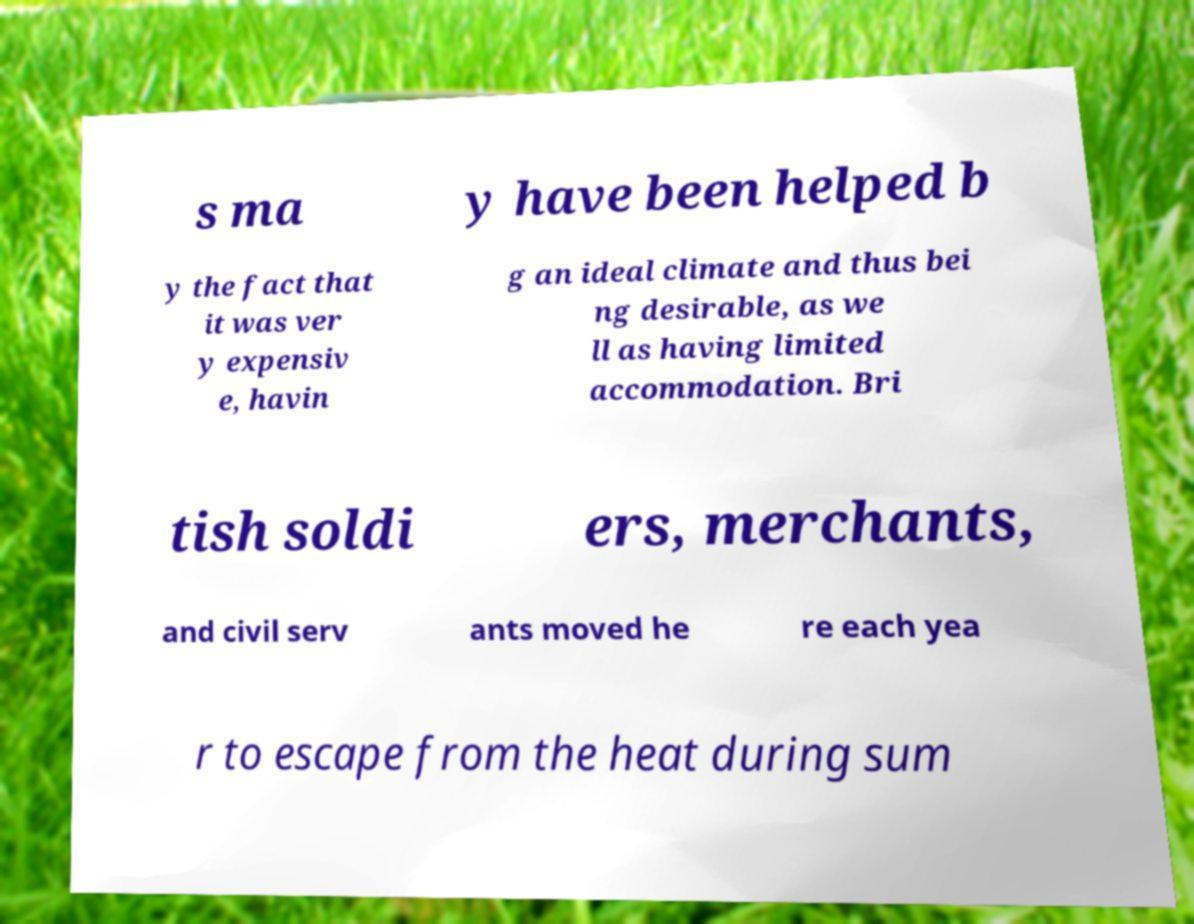Could you extract and type out the text from this image? s ma y have been helped b y the fact that it was ver y expensiv e, havin g an ideal climate and thus bei ng desirable, as we ll as having limited accommodation. Bri tish soldi ers, merchants, and civil serv ants moved he re each yea r to escape from the heat during sum 